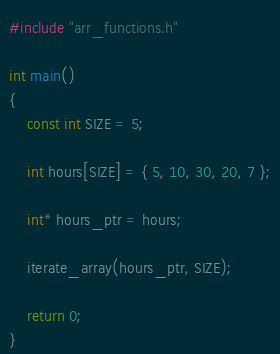<code> <loc_0><loc_0><loc_500><loc_500><_C++_>#include "arr_functions.h"

int main() 
{
	const int SIZE = 5;

	int hours[SIZE] = { 5, 10, 30, 20, 7 };

	int* hours_ptr = hours;

	iterate_array(hours_ptr, SIZE);

	return 0;
}</code> 